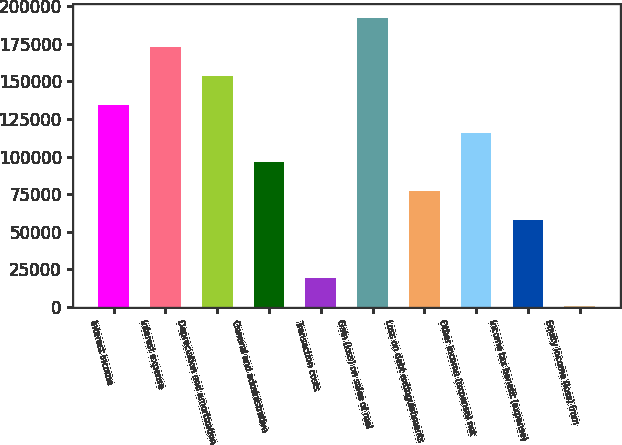Convert chart to OTSL. <chart><loc_0><loc_0><loc_500><loc_500><bar_chart><fcel>Interest income<fcel>Interest expense<fcel>Depreciation and amortization<fcel>General and administrative<fcel>Transaction costs<fcel>Gain (loss) on sales of real<fcel>Loss on debt extinguishments<fcel>Other income (expense) net<fcel>Income tax benefit (expense)<fcel>Equity income (loss) from<nl><fcel>134498<fcel>172795<fcel>153646<fcel>96201<fcel>19607.4<fcel>191943<fcel>77052.6<fcel>115349<fcel>57904.2<fcel>459<nl></chart> 